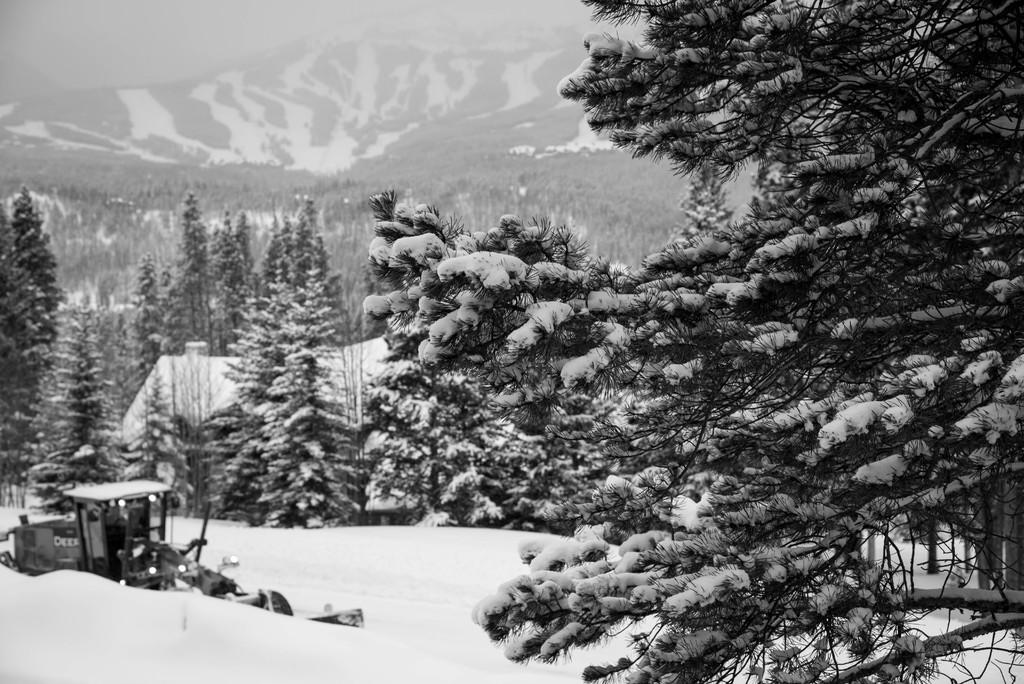What type of picture is in the image? The image contains a black and white picture. What is the main subject of the picture? The picture depicts a vehicle. Where is the vehicle located in the image? The vehicle is parked in the snow. What can be seen in the background of the image? There is a group of trees and mountains visible in the background of the image. What else is visible in the background of the image? The sky is visible in the background of the image. What type of net is being used to catch the representative in the image? There is no net or representative present in the image; it features a black and white picture of a vehicle parked in the snow with a background of trees, mountains, and sky. 